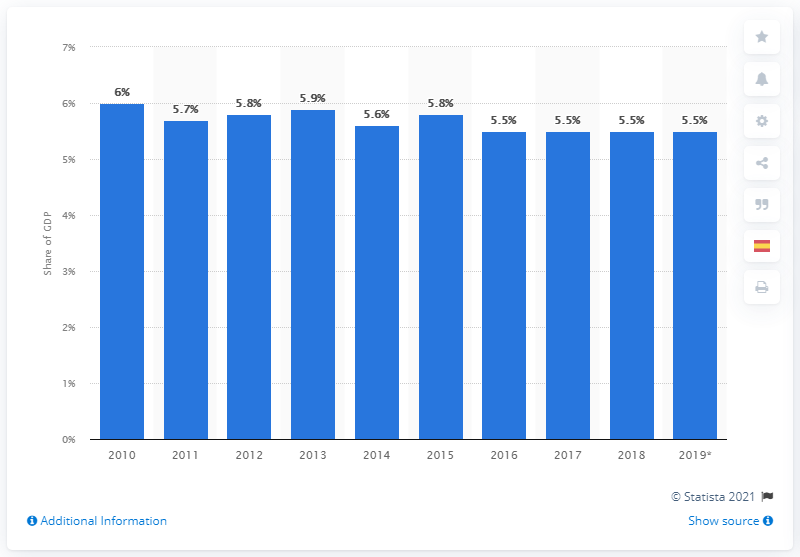Draw attention to some important aspects in this diagram. In 2019, healthcare expenditure accounted for approximately 5.5% of Mexico's Gross Domestic Product (GDP), reflecting the country's commitment to providing accessible and affordable healthcare to its citizens. 